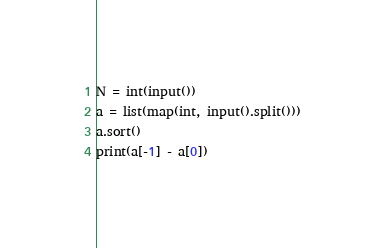<code> <loc_0><loc_0><loc_500><loc_500><_Python_>N = int(input())
a = list(map(int, input().split()))
a.sort()
print(a[-1] - a[0])</code> 